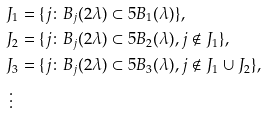<formula> <loc_0><loc_0><loc_500><loc_500>& J _ { 1 } = \{ j \colon B _ { j } ( 2 \lambda ) \subset 5 B _ { 1 } ( \lambda ) \} , \\ & J _ { 2 } = \{ j \colon B _ { j } ( 2 \lambda ) \subset 5 B _ { 2 } ( \lambda ) , j \notin J _ { 1 } \} , \\ & J _ { 3 } = \{ j \colon B _ { j } ( 2 \lambda ) \subset 5 B _ { 3 } ( \lambda ) , j \notin J _ { 1 } \cup J _ { 2 } \} , \\ & \, \vdots</formula> 